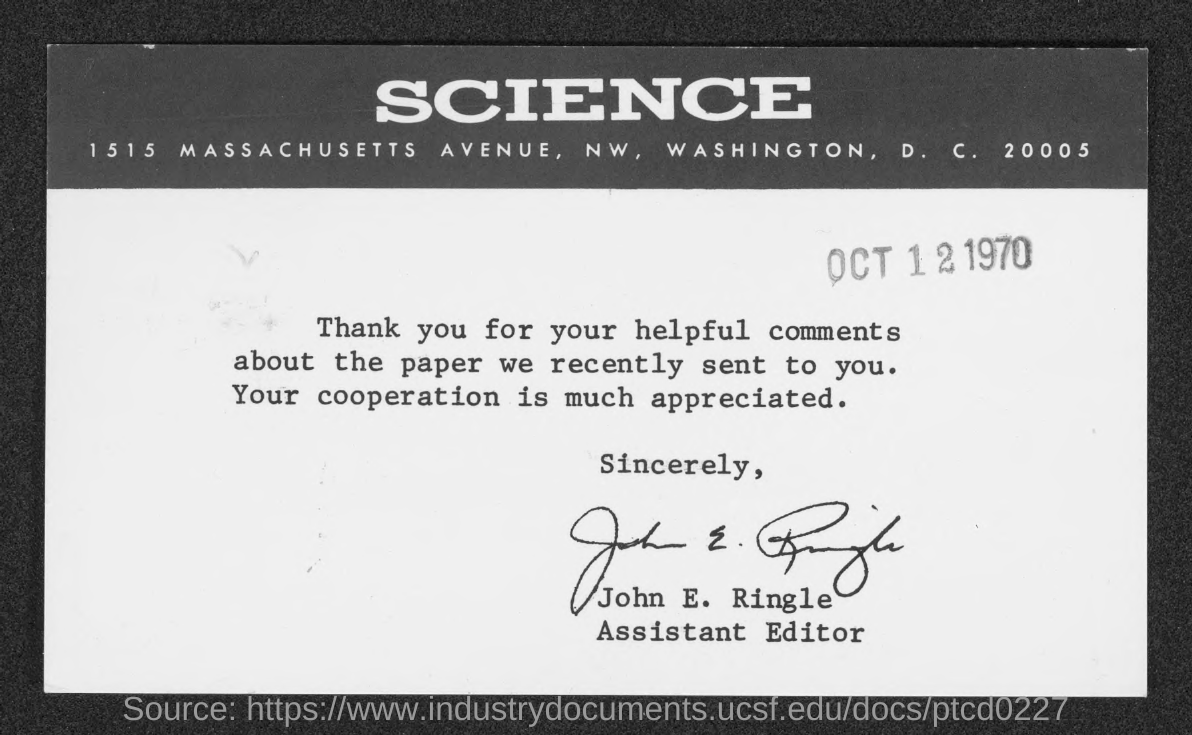Highlight a few significant elements in this photo. The memorandum is dated October 12, 1970. John E. Ringle is the assistant editor. 